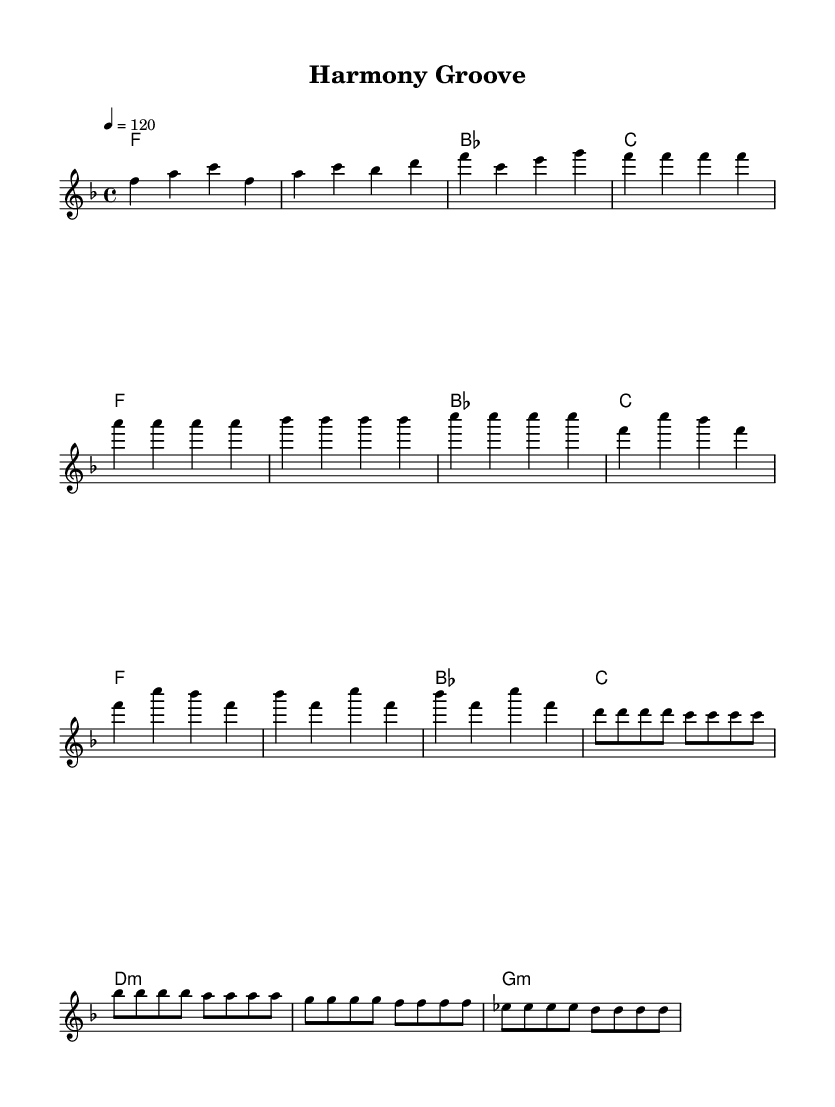What is the key signature of this music? The key signature is F major, which includes one flat (B flat). This can be determined by examining the clef and the key signature indicated at the beginning of the sheet music.
Answer: F major What is the time signature of the piece? The time signature is 4/4, which is indicated at the beginning of the sheet music. This means there are four beats in a measure, and the quarter note receives one beat.
Answer: 4/4 What is the tempo marking for the piece? The tempo marking indicates a speed of 120 beats per minute, as shown in the tempo line above the staff. This tells performers how fast to play the music.
Answer: 120 How many measures are there in the intro? The intro consists of two measures, which can be visually counted from the start of the piece until the end of that section. Each measure is separated by a vertical line.
Answer: 2 What is the chord in the first measure of the intro? The chord in the first measure is F major, which is indicated in the chord names section. The chord symbols correspond to the notes played in that measure.
Answer: F Which section has a different chord progression compared to the verse? The bridge section has a different chord progression compared to the verse. The bridge uses D minor and G minor chords, while the verse uses F major and B flat major chords.
Answer: Bridge What type of music does this sheet represent? This sheet represents disco music, characterized by its rhythmic grooves and upbeat tempo, often focusing on themes of social harmony and unity. The arrangement and style of the melody and chords reflect disco elements.
Answer: Disco 